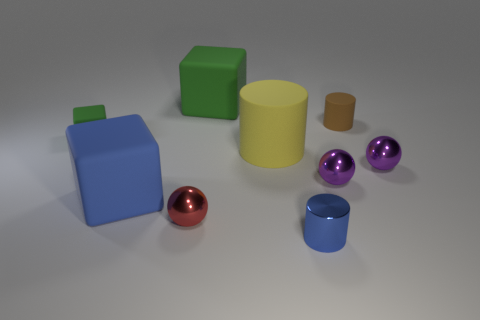Subtract all spheres. How many objects are left? 6 Subtract all small brown cylinders. How many cylinders are left? 2 Add 1 purple things. How many purple things exist? 3 Subtract all yellow cylinders. How many cylinders are left? 2 Subtract 0 cyan cubes. How many objects are left? 9 Subtract 2 blocks. How many blocks are left? 1 Subtract all red cylinders. Subtract all red balls. How many cylinders are left? 3 Subtract all gray cylinders. How many green spheres are left? 0 Subtract all small red metal balls. Subtract all small red metallic balls. How many objects are left? 7 Add 1 small blue shiny cylinders. How many small blue shiny cylinders are left? 2 